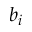Convert formula to latex. <formula><loc_0><loc_0><loc_500><loc_500>b _ { i }</formula> 